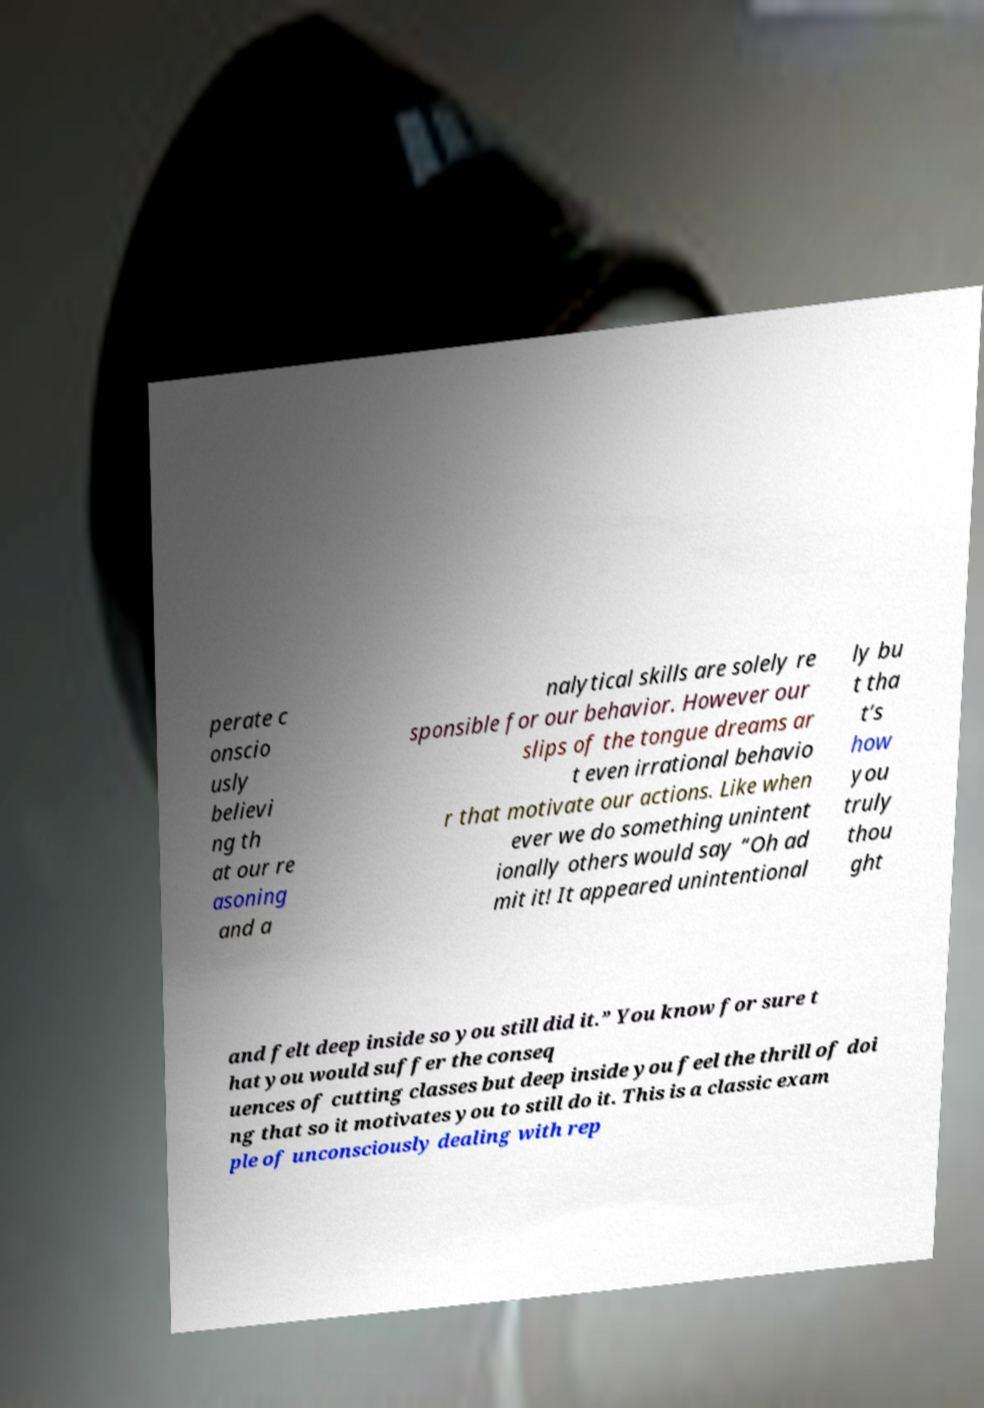I need the written content from this picture converted into text. Can you do that? perate c onscio usly believi ng th at our re asoning and a nalytical skills are solely re sponsible for our behavior. However our slips of the tongue dreams ar t even irrational behavio r that motivate our actions. Like when ever we do something unintent ionally others would say “Oh ad mit it! It appeared unintentional ly bu t tha t’s how you truly thou ght and felt deep inside so you still did it.” You know for sure t hat you would suffer the conseq uences of cutting classes but deep inside you feel the thrill of doi ng that so it motivates you to still do it. This is a classic exam ple of unconsciously dealing with rep 